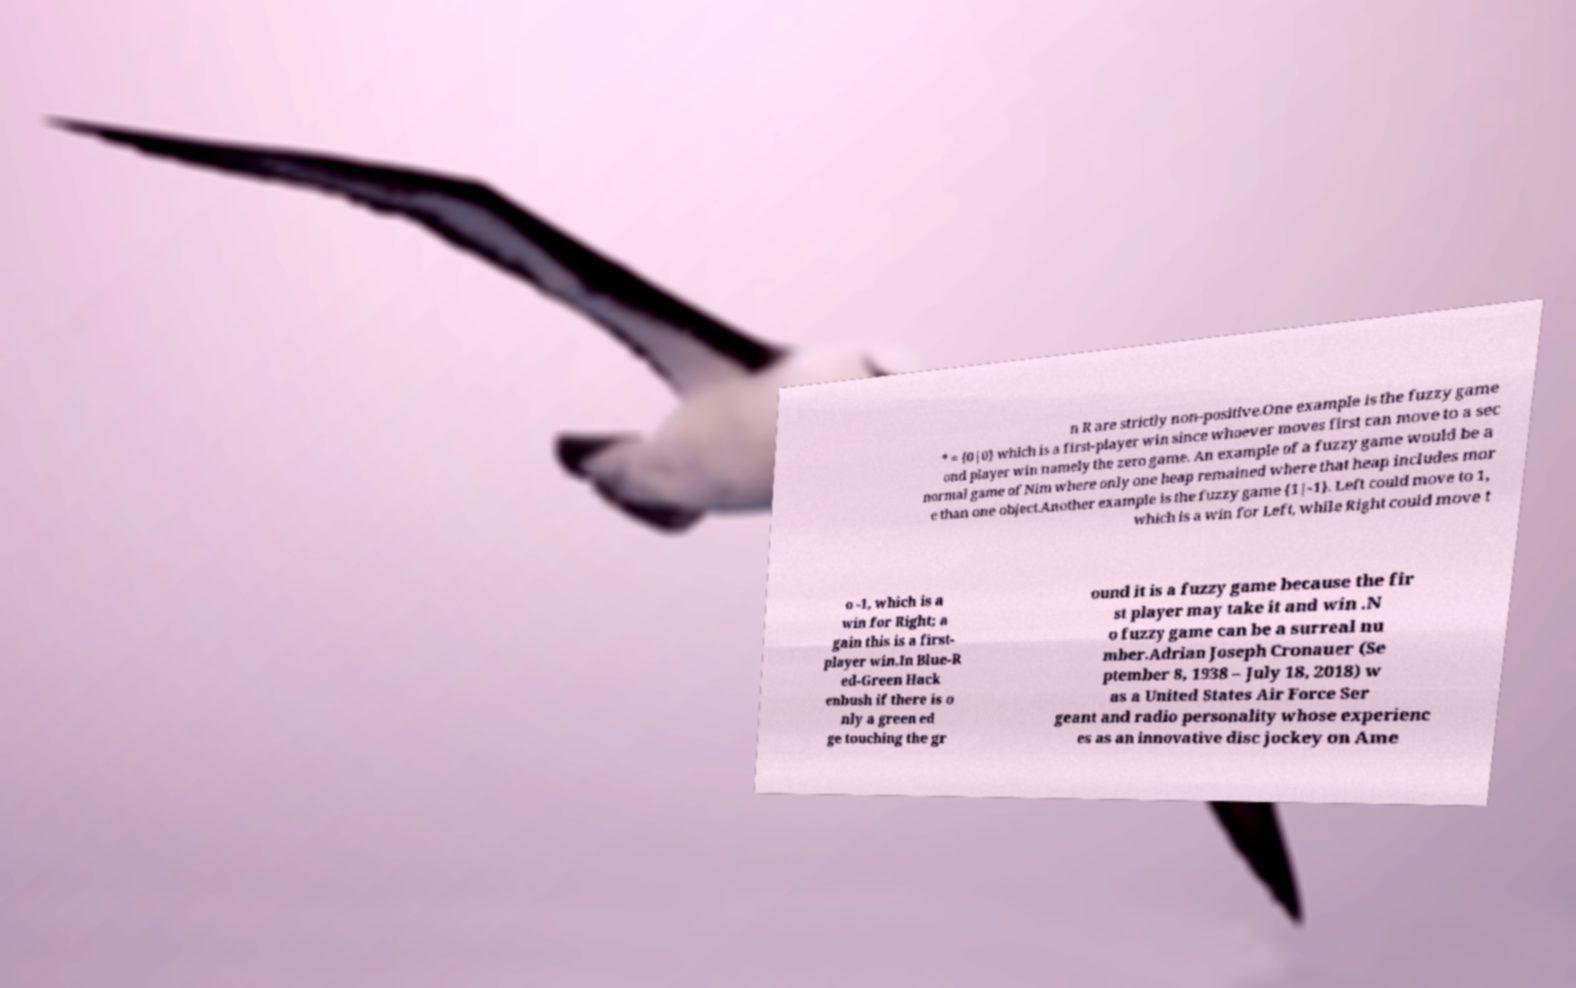There's text embedded in this image that I need extracted. Can you transcribe it verbatim? n R are strictly non-positive.One example is the fuzzy game * = {0|0} which is a first-player win since whoever moves first can move to a sec ond player win namely the zero game. An example of a fuzzy game would be a normal game of Nim where only one heap remained where that heap includes mor e than one object.Another example is the fuzzy game {1|-1}. Left could move to 1, which is a win for Left, while Right could move t o -1, which is a win for Right; a gain this is a first- player win.In Blue-R ed-Green Hack enbush if there is o nly a green ed ge touching the gr ound it is a fuzzy game because the fir st player may take it and win .N o fuzzy game can be a surreal nu mber.Adrian Joseph Cronauer (Se ptember 8, 1938 – July 18, 2018) w as a United States Air Force Ser geant and radio personality whose experienc es as an innovative disc jockey on Ame 